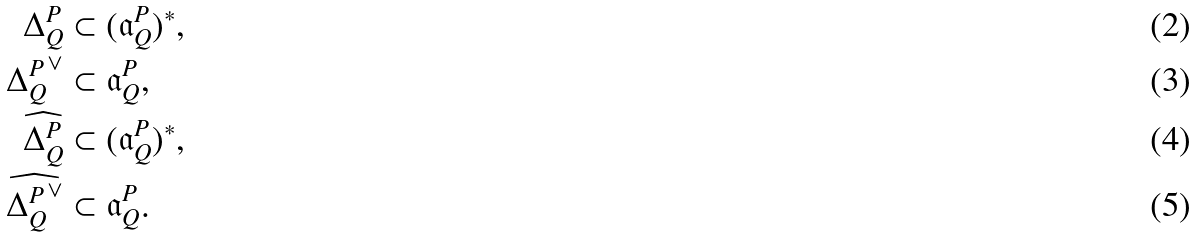Convert formula to latex. <formula><loc_0><loc_0><loc_500><loc_500>\Delta ^ { P } _ { Q } & \subset ( \mathfrak { a } ^ { P } _ { Q } ) ^ { * } , \\ { \Delta ^ { P } _ { Q } } ^ { \vee } & \subset \mathfrak { a } ^ { P } _ { Q } , \\ \widehat { \Delta ^ { P } _ { Q } } & \subset ( \mathfrak { a } ^ { P } _ { Q } ) ^ { * } , \\ \widehat { { \Delta ^ { P } _ { Q } } ^ { \vee } } & \subset \mathfrak { a } ^ { P } _ { Q } .</formula> 